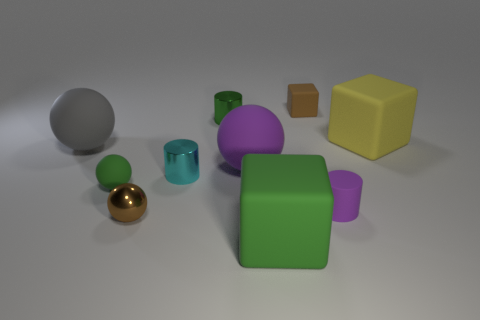How would you interpret the arrangement of the shapes and colors in this image? The arrangement of shapes and colors could be seen as a study in contrasts and diversity, showcasing various geometrical forms and a spectrum of colors that might symbolize variety and complexity in a structured environment. Could there be a symbolic meaning behind the positioning of the objects? If one were to interpret the positioning symbolically, it might represent hierarchical or spatial relationships. For instance, the larger objects could symbolize dominance or importance, while the smaller ones might indicate subordination or smaller scale significance. 